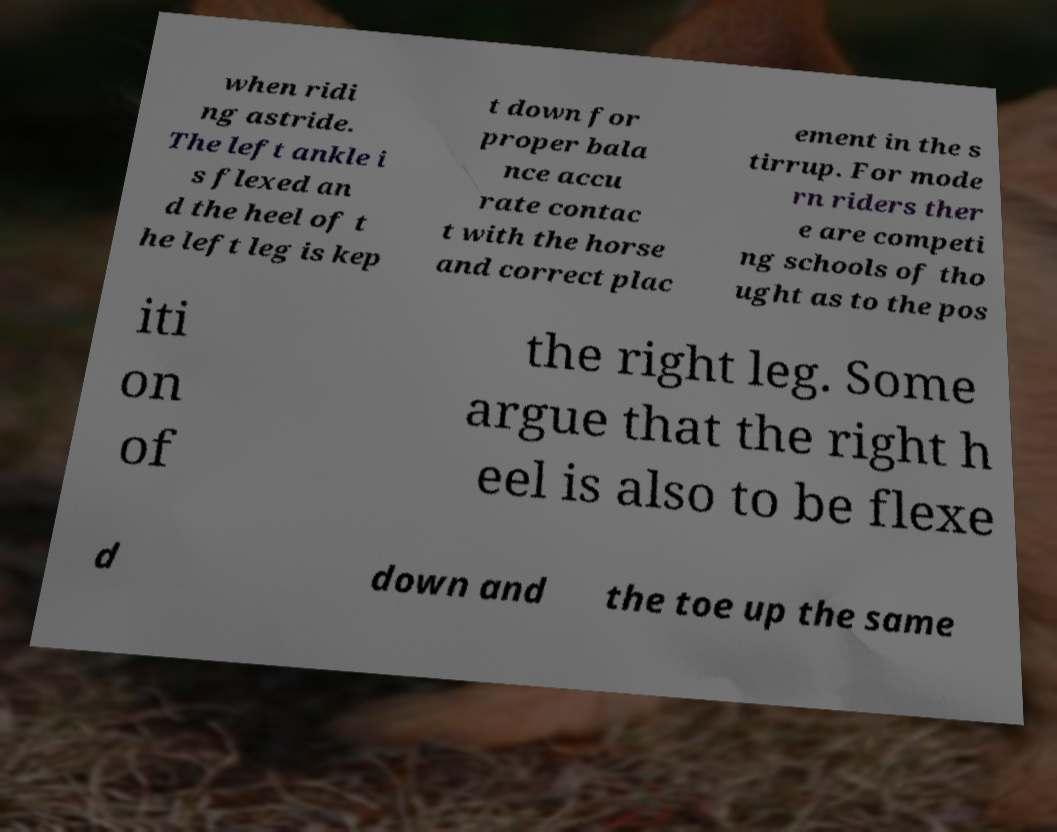For documentation purposes, I need the text within this image transcribed. Could you provide that? when ridi ng astride. The left ankle i s flexed an d the heel of t he left leg is kep t down for proper bala nce accu rate contac t with the horse and correct plac ement in the s tirrup. For mode rn riders ther e are competi ng schools of tho ught as to the pos iti on of the right leg. Some argue that the right h eel is also to be flexe d down and the toe up the same 